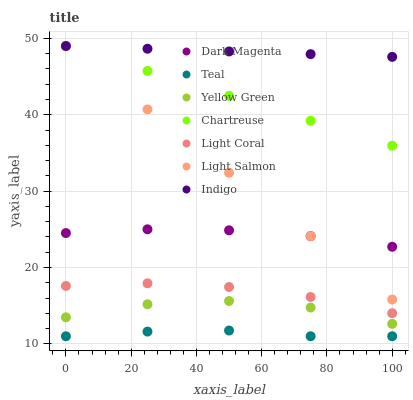Does Teal have the minimum area under the curve?
Answer yes or no. Yes. Does Indigo have the maximum area under the curve?
Answer yes or no. Yes. Does Dark Magenta have the minimum area under the curve?
Answer yes or no. No. Does Dark Magenta have the maximum area under the curve?
Answer yes or no. No. Is Light Salmon the smoothest?
Answer yes or no. Yes. Is Yellow Green the roughest?
Answer yes or no. Yes. Is Indigo the smoothest?
Answer yes or no. No. Is Indigo the roughest?
Answer yes or no. No. Does Teal have the lowest value?
Answer yes or no. Yes. Does Dark Magenta have the lowest value?
Answer yes or no. No. Does Chartreuse have the highest value?
Answer yes or no. Yes. Does Dark Magenta have the highest value?
Answer yes or no. No. Is Teal less than Indigo?
Answer yes or no. Yes. Is Chartreuse greater than Teal?
Answer yes or no. Yes. Does Light Salmon intersect Dark Magenta?
Answer yes or no. Yes. Is Light Salmon less than Dark Magenta?
Answer yes or no. No. Is Light Salmon greater than Dark Magenta?
Answer yes or no. No. Does Teal intersect Indigo?
Answer yes or no. No. 